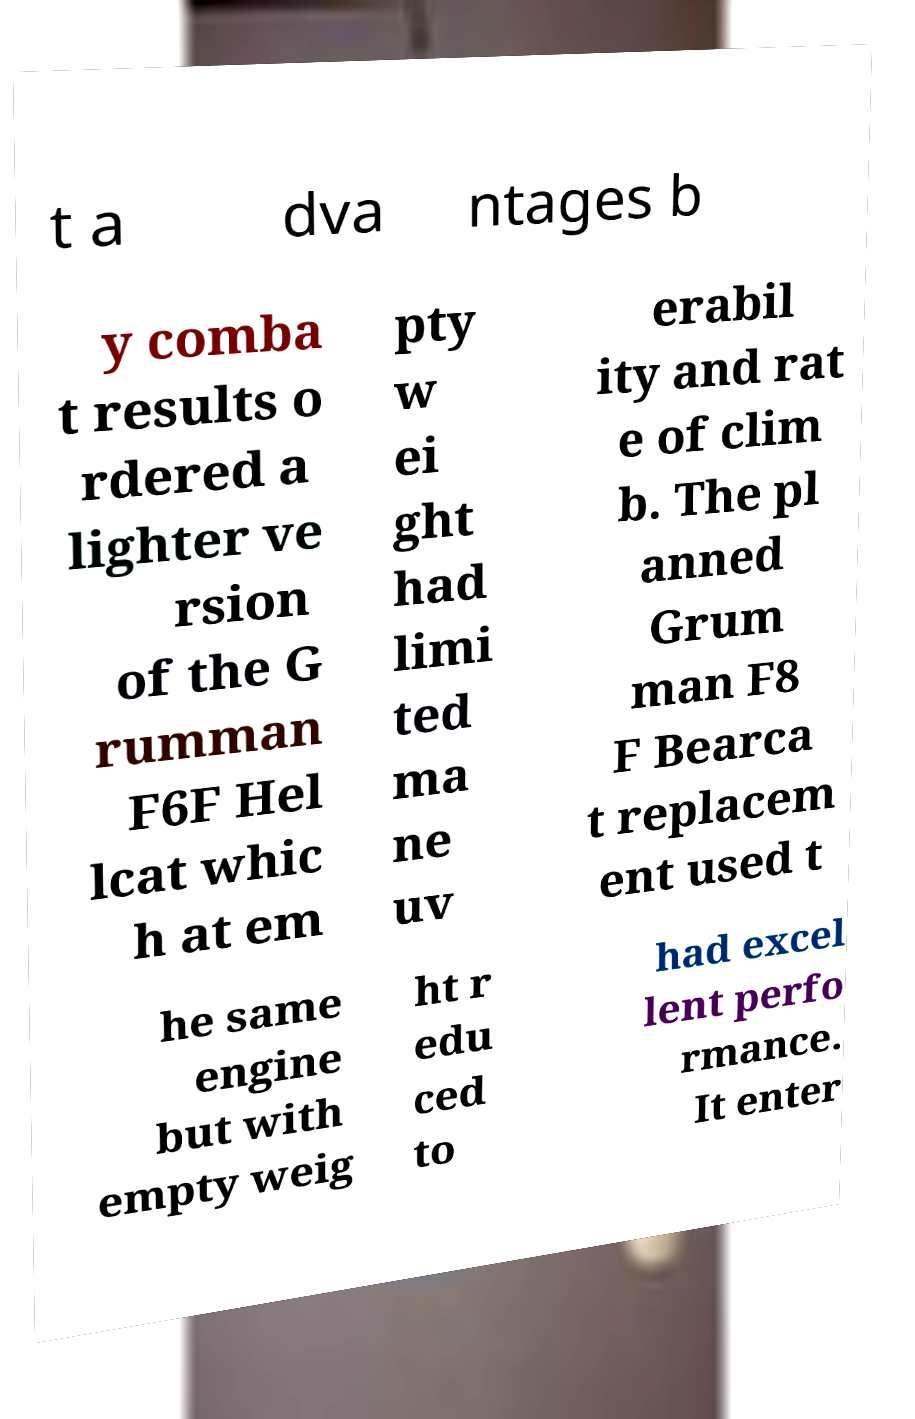Can you read and provide the text displayed in the image?This photo seems to have some interesting text. Can you extract and type it out for me? t a dva ntages b y comba t results o rdered a lighter ve rsion of the G rumman F6F Hel lcat whic h at em pty w ei ght had limi ted ma ne uv erabil ity and rat e of clim b. The pl anned Grum man F8 F Bearca t replacem ent used t he same engine but with empty weig ht r edu ced to had excel lent perfo rmance. It enter 